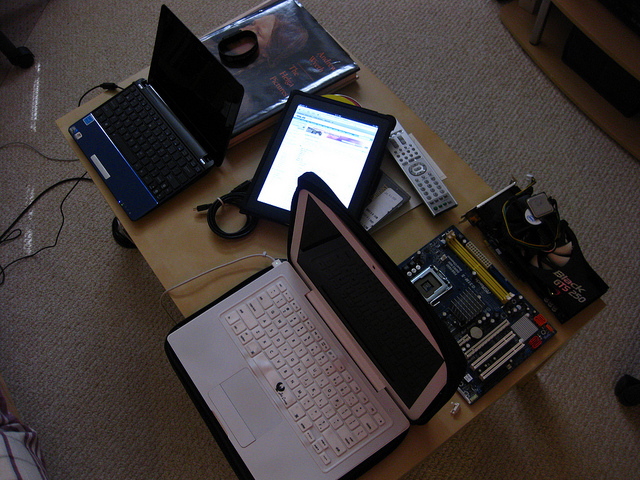<image>Whose picture is on the Kindle? I don't know whose picture is on the Kindle. It can be the owner's or no one's. Whose picture is on the Kindle? I don't know whose picture is on the Kindle. It can be anyone's or there might be no picture at all. 